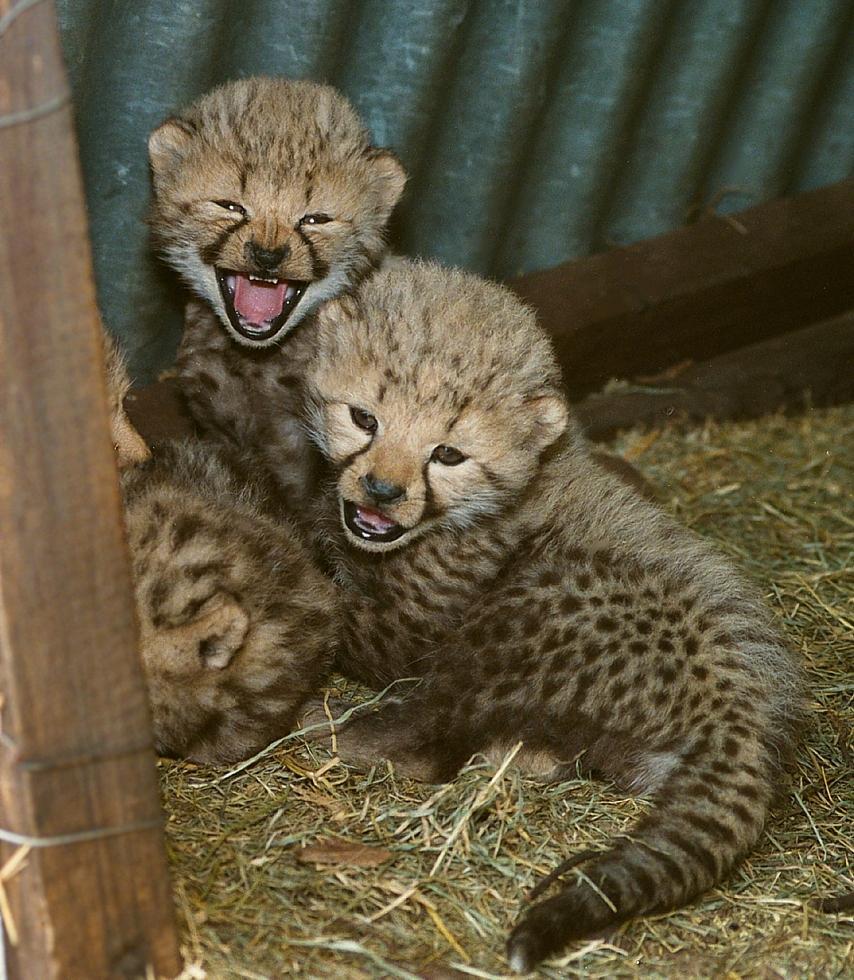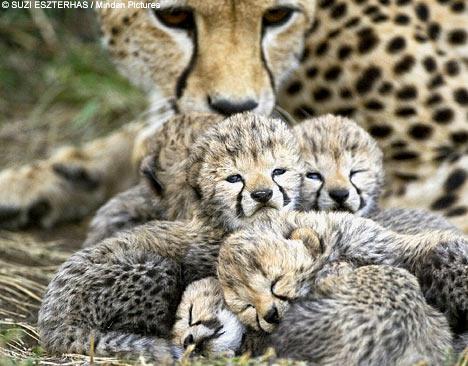The first image is the image on the left, the second image is the image on the right. Examine the images to the left and right. Is the description "The picture on the left shows at least two baby cheetah sitting down next to their mother." accurate? Answer yes or no. No. 